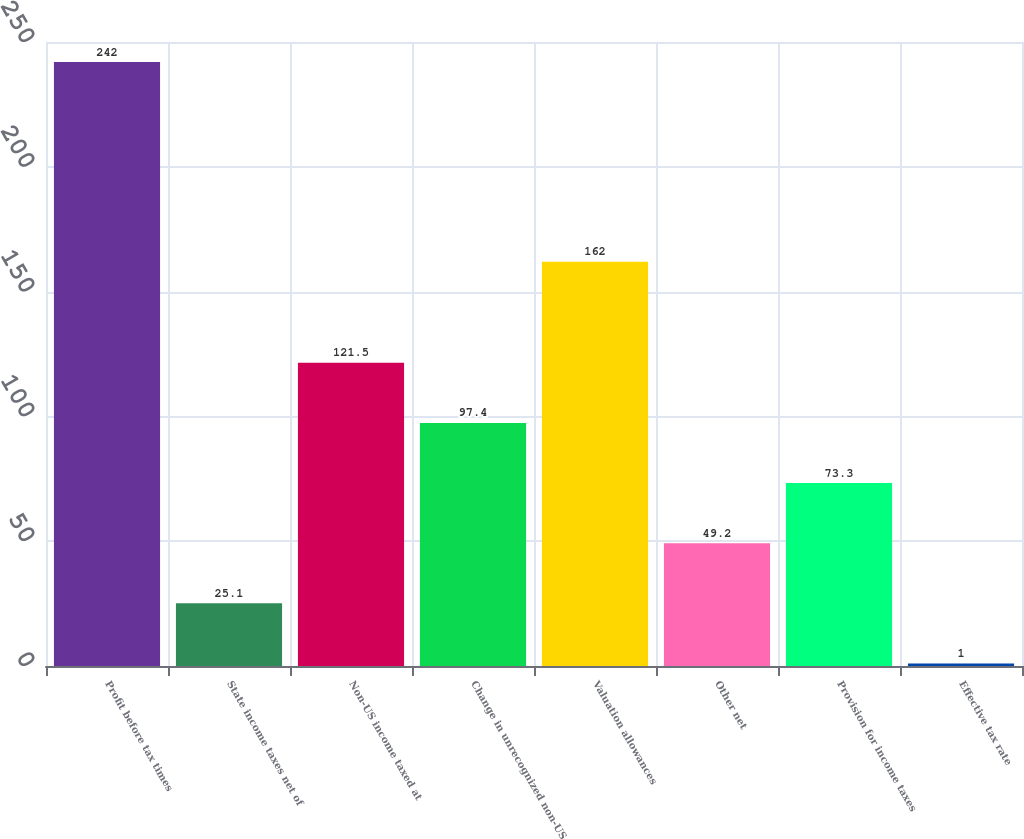Convert chart. <chart><loc_0><loc_0><loc_500><loc_500><bar_chart><fcel>Profit before tax times<fcel>State income taxes net of<fcel>Non-US income taxed at<fcel>Change in unrecognized non-US<fcel>Valuation allowances<fcel>Other net<fcel>Provision for income taxes<fcel>Effective tax rate<nl><fcel>242<fcel>25.1<fcel>121.5<fcel>97.4<fcel>162<fcel>49.2<fcel>73.3<fcel>1<nl></chart> 